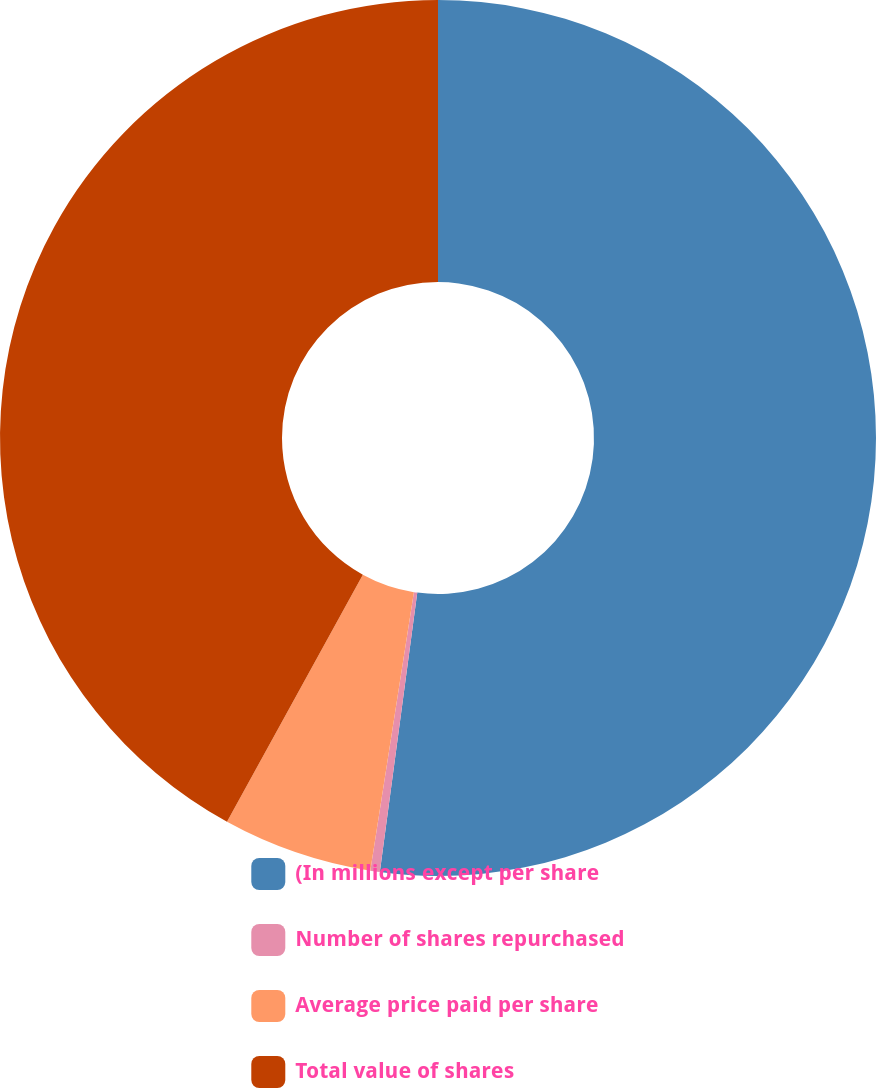Convert chart. <chart><loc_0><loc_0><loc_500><loc_500><pie_chart><fcel>(In millions except per share<fcel>Number of shares repurchased<fcel>Average price paid per share<fcel>Total value of shares<nl><fcel>52.12%<fcel>0.35%<fcel>5.53%<fcel>42.0%<nl></chart> 